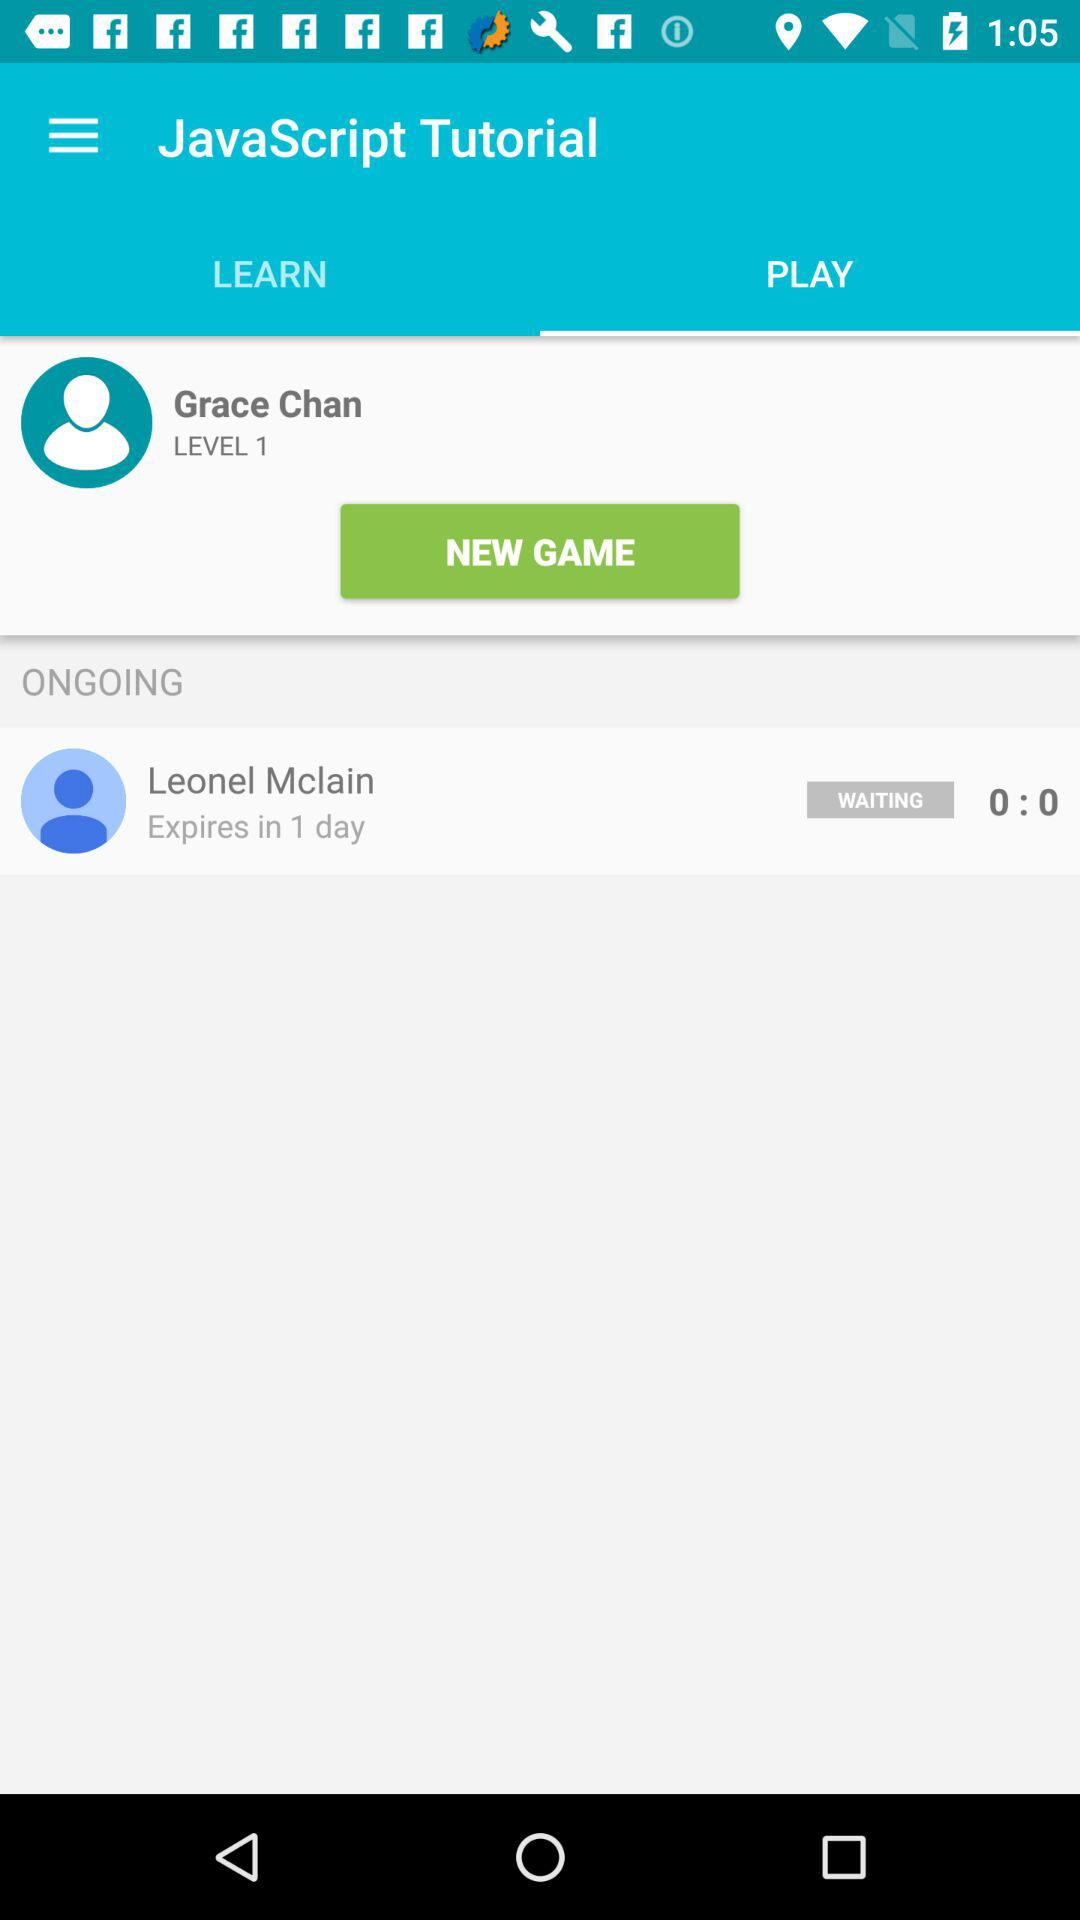What tab is selected for the JavaScript tutorial? The selected tab is "PLAY". 